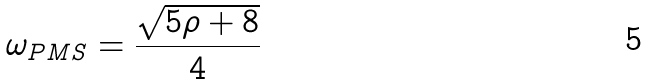Convert formula to latex. <formula><loc_0><loc_0><loc_500><loc_500>\omega _ { P M S } = \frac { \sqrt { 5 \rho + 8 } } { 4 }</formula> 